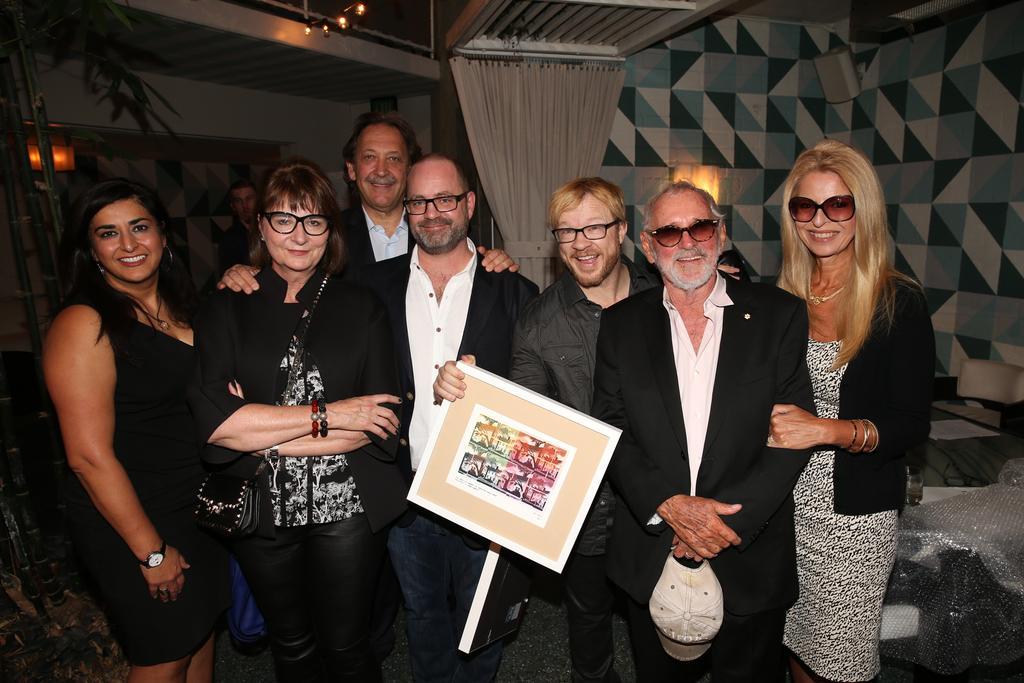Describe this image in one or two sentences. In this image, we can see people standing and some are wearing glasses and one of them is holding a board and we can see a person holding a cap. In the background, there are trees, lights, a curtain and there is a wall. 